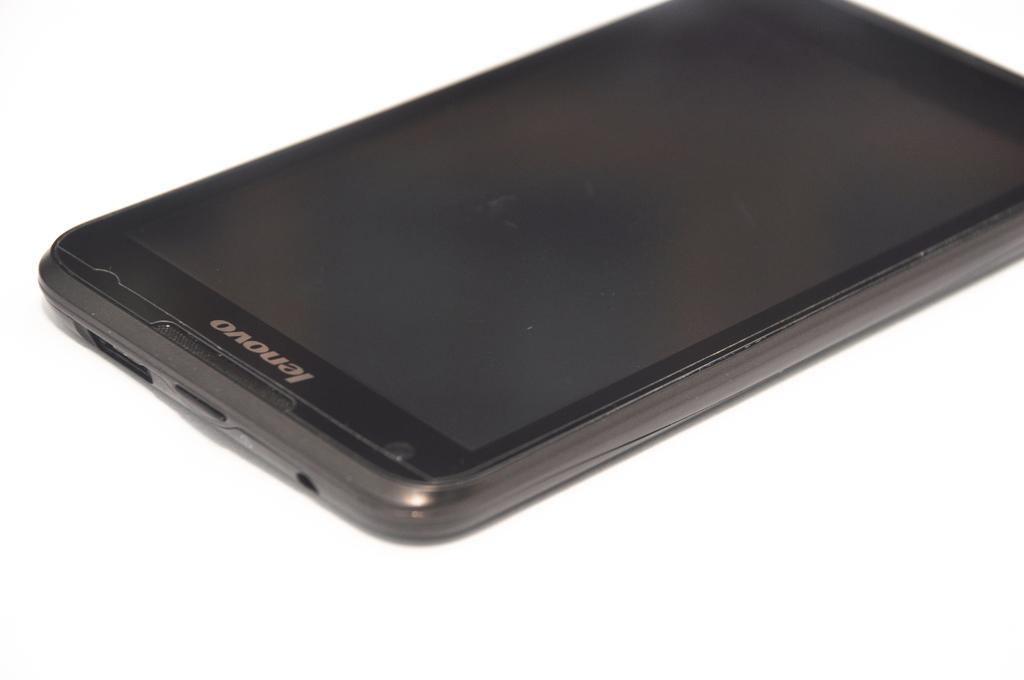<image>
Describe the image concisely. A black Lenovo smartphone lies on a white background. 